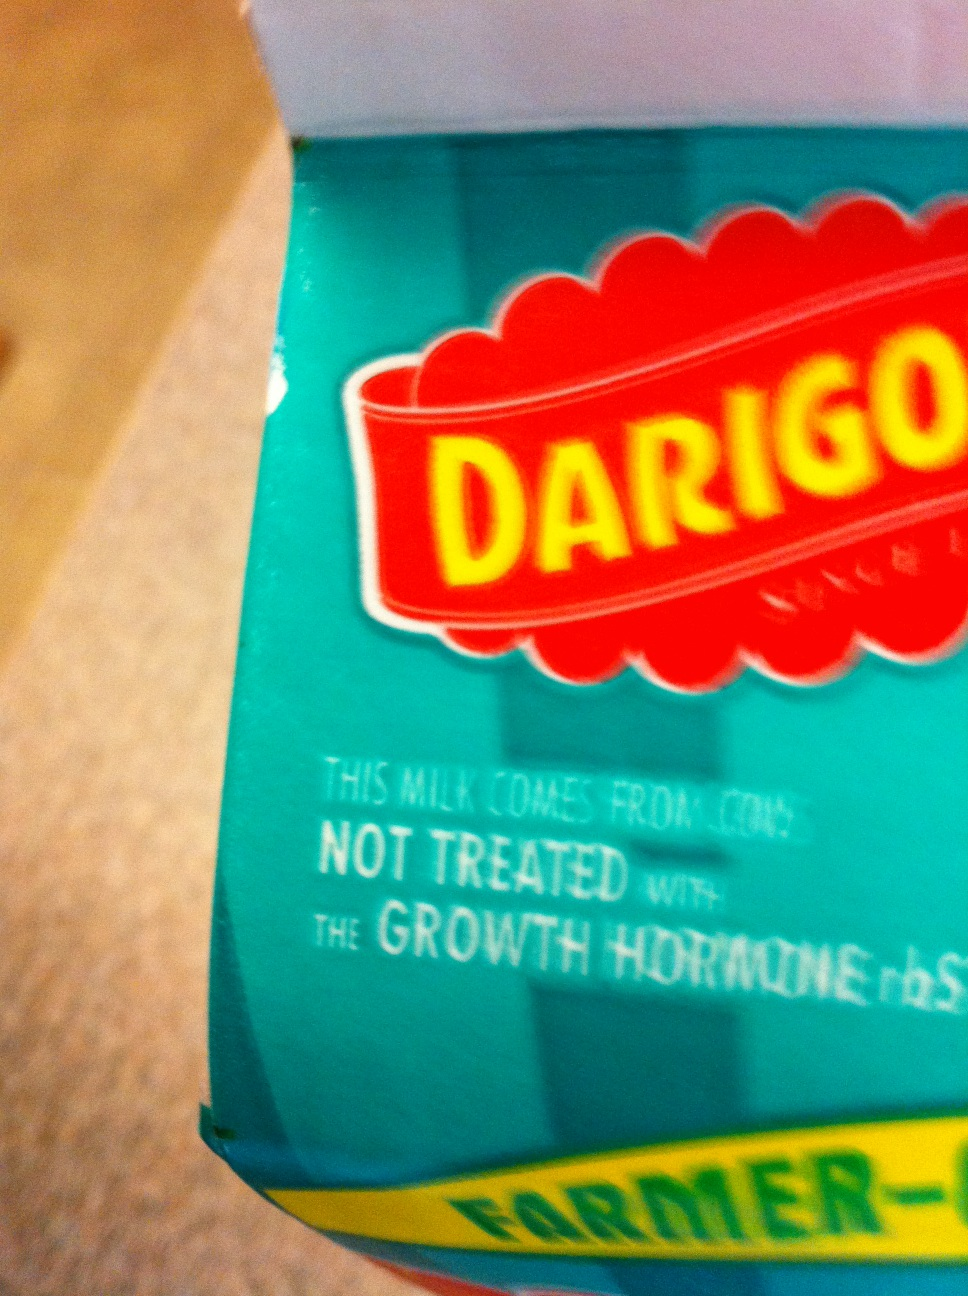Can you tell me anything about the brand or label shown on this milk carton? The photo is blurry, but we can make out that the milk is from a brand called 'DARIGO', and there's a statement that says, 'This milk comes from cows not treated with the growth hormone rBST'. This indicates the milk is sourced from cows without the use of certain artificial growth hormones, potentially appealing to those looking for more natural dairy products. 